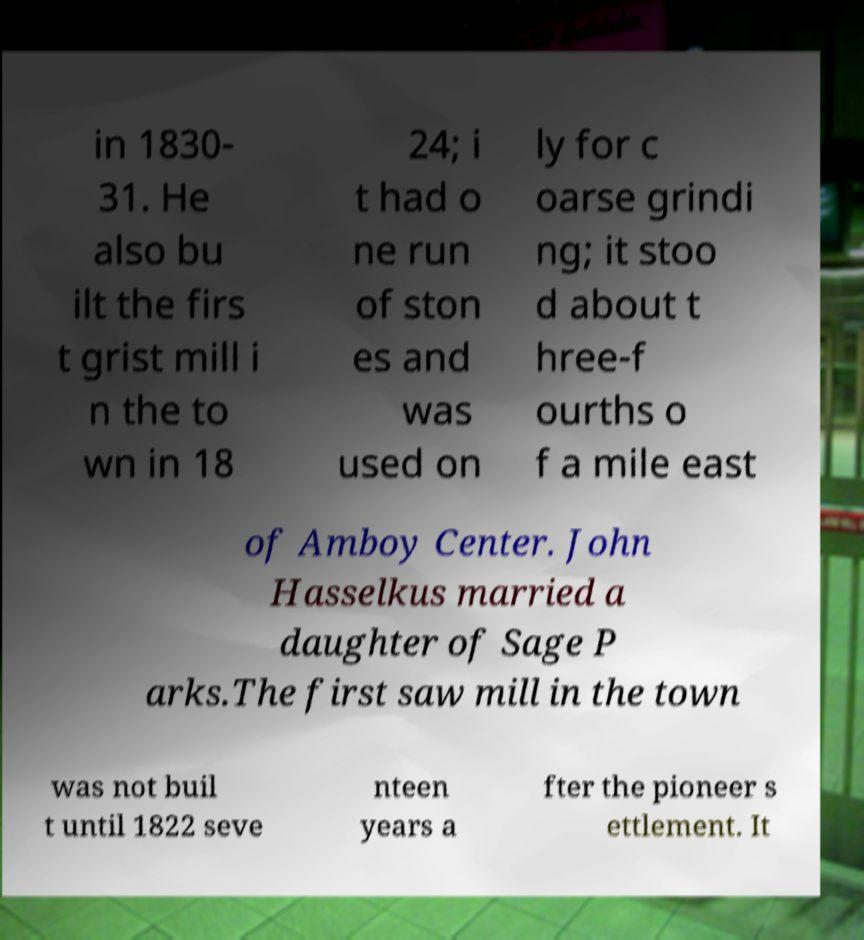I need the written content from this picture converted into text. Can you do that? in 1830- 31. He also bu ilt the firs t grist mill i n the to wn in 18 24; i t had o ne run of ston es and was used on ly for c oarse grindi ng; it stoo d about t hree-f ourths o f a mile east of Amboy Center. John Hasselkus married a daughter of Sage P arks.The first saw mill in the town was not buil t until 1822 seve nteen years a fter the pioneer s ettlement. It 